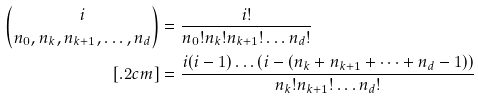Convert formula to latex. <formula><loc_0><loc_0><loc_500><loc_500>\binom { i } { n _ { 0 } , n _ { k } , n _ { k + 1 } , \dots , n _ { d } } & = \frac { i ! } { n _ { 0 } ! n _ { k } ! n _ { k + 1 } ! \dots n _ { d } ! } \\ [ . 2 c m ] & = \frac { i ( i - 1 ) \dots ( i - ( n _ { k } + n _ { k + 1 } + \dots + n _ { d } - 1 ) ) } { n _ { k } ! n _ { k + 1 } ! \dots n _ { d } ! }</formula> 